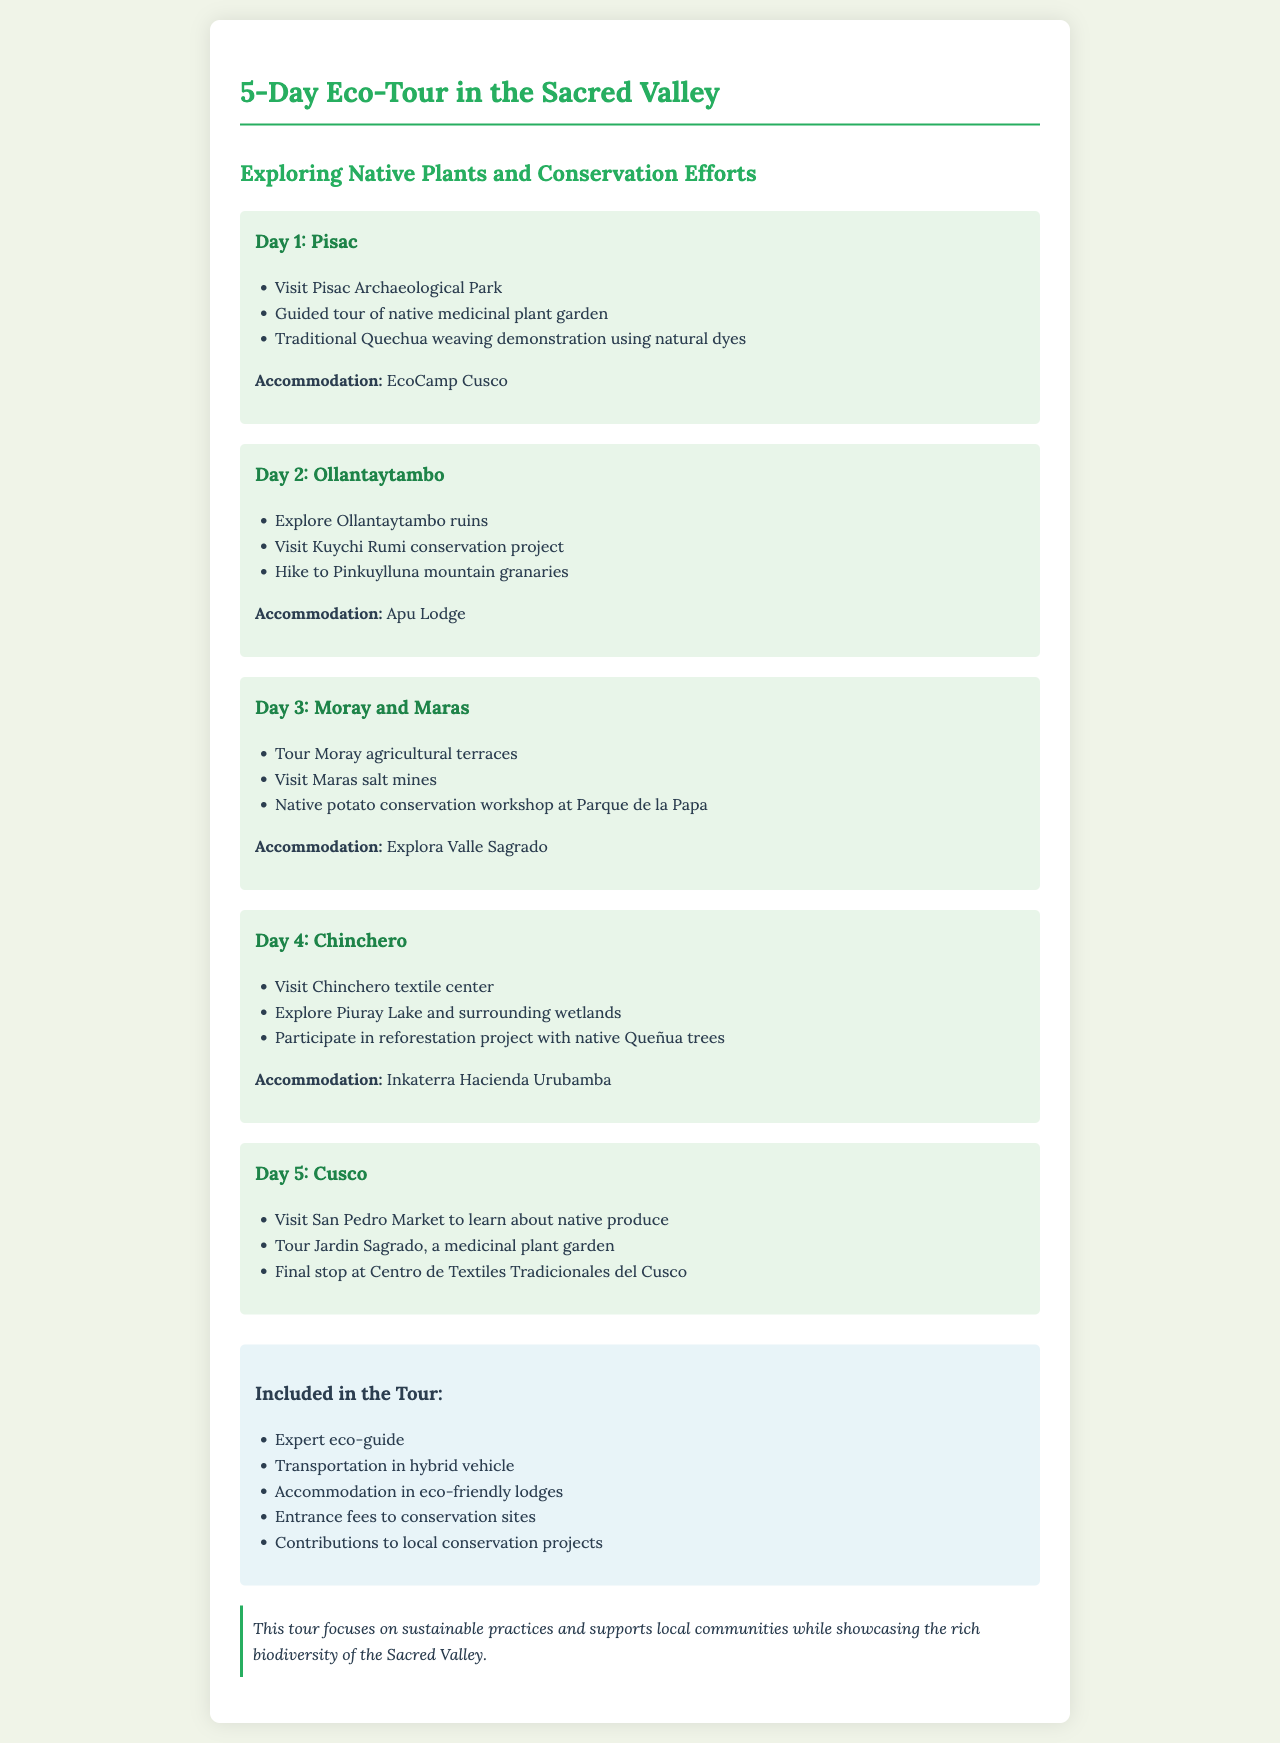What is the accommodation for Day 1? The accommodation listed for Day 1 is EcoCamp Cusco.
Answer: EcoCamp Cusco What activity happens on Day 2? An activity listed for Day 2 is visiting the Kuychi Rumi conservation project.
Answer: Visit Kuychi Rumi conservation project What is included in the tour? The document lists several items, including transportation in a hybrid vehicle as part of the inclusions.
Answer: Transportation in hybrid vehicle How many days does the eco-tour last? The eco-tour itinerary spans over a total of 5 days.
Answer: 5 Which native plant is mentioned on Day 4? The native plant mentioned for Day 4 is the Queñua tree, as part of a reforestation project.
Answer: Queñua trees What is the focus of the tour? The focus of the tour is on sustainable practices and supporting local communities.
Answer: Sustainable practices What location is visited on Day 3? On Day 3, the Moray agricultural terraces are visited.
Answer: Moray agricultural terraces 